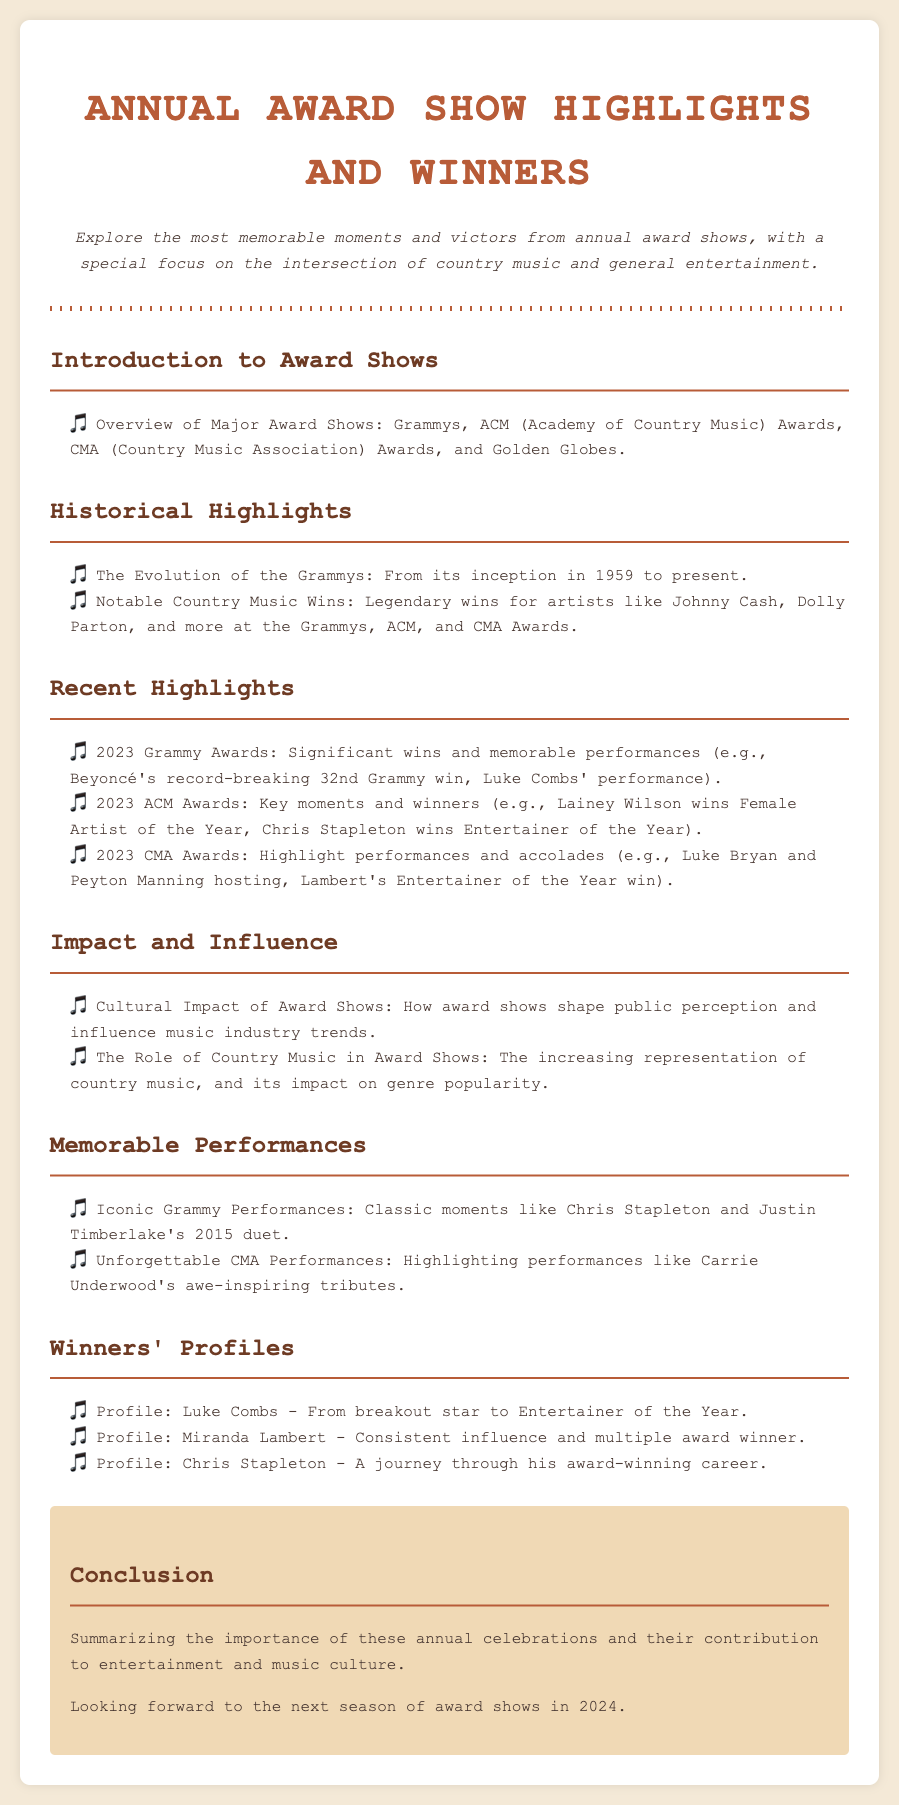what year did the Grammys start? The document states that the Grammys began in 1959.
Answer: 1959 who won Female Artist of the Year at the 2023 ACM Awards? The document indicates that Lainey Wilson won this award.
Answer: Lainey Wilson what notable performance is mentioned from the 2023 Grammy Awards? The document mentions Beyoncé's record-breaking 32nd Grammy win as a significant moment.
Answer: Beyoncé's record-breaking 32nd Grammy win which artist is highlighted for their consistent influence and multiple awards? The document provides a profile of Miranda Lambert as this artist.
Answer: Miranda Lambert what is the focus of the 'Impact and Influence' section? This section highlights how award shows shape public perception and influence music industry trends.
Answer: Cultural Impact of Award Shows how many Grammys did Beyoncé win in total according to the document? The total number mentioned is significant with Beyoncés record-breaking 32nd Grammy win being noted.
Answer: 32 who hosted the 2023 CMA Awards? The document states that Luke Bryan and Peyton Manning co-hosted the event.
Answer: Luke Bryan and Peyton Manning what is the main theme of the 'Winners' Profiles' section? The section focuses on providing individual profiles of award-winning artists in country music.
Answer: Individual profiles of award-winning artists which performance is considered iconic from the Grammy Awards? The document mentions Chris Stapleton and Justin Timberlake's 2015 duet as an iconic performance.
Answer: Chris Stapleton and Justin Timberlake's 2015 duet 